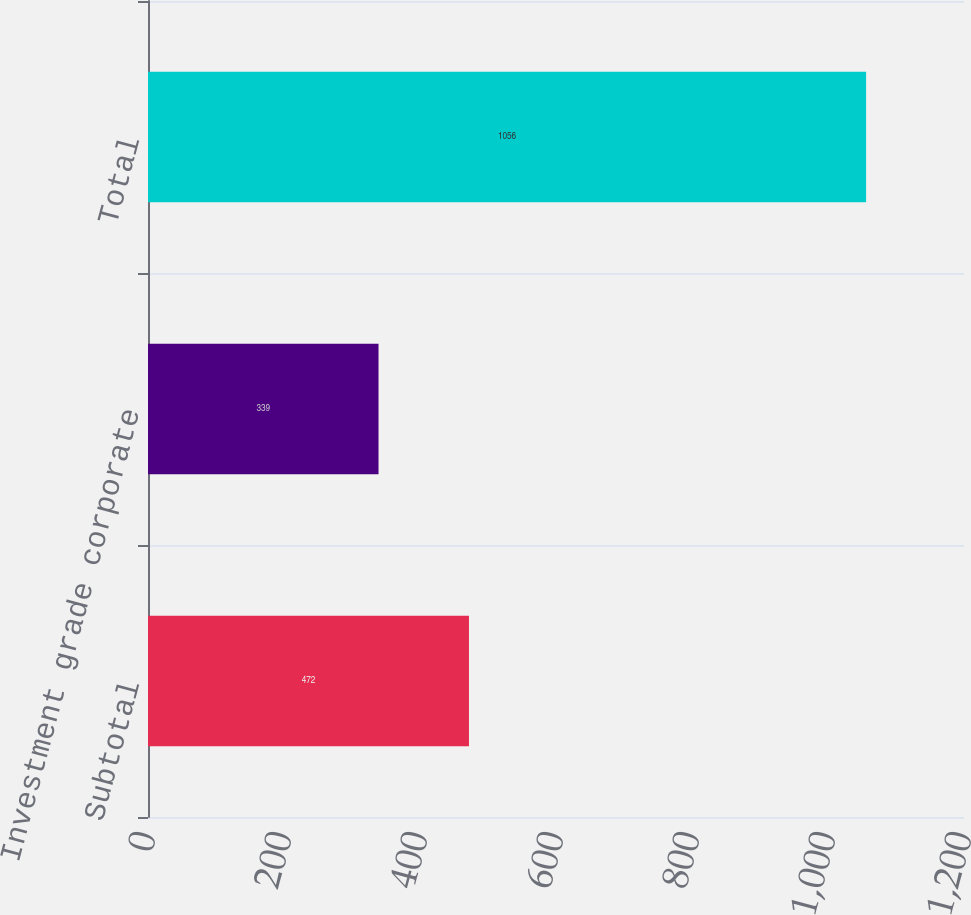Convert chart. <chart><loc_0><loc_0><loc_500><loc_500><bar_chart><fcel>Subtotal<fcel>Investment grade corporate<fcel>Total<nl><fcel>472<fcel>339<fcel>1056<nl></chart> 